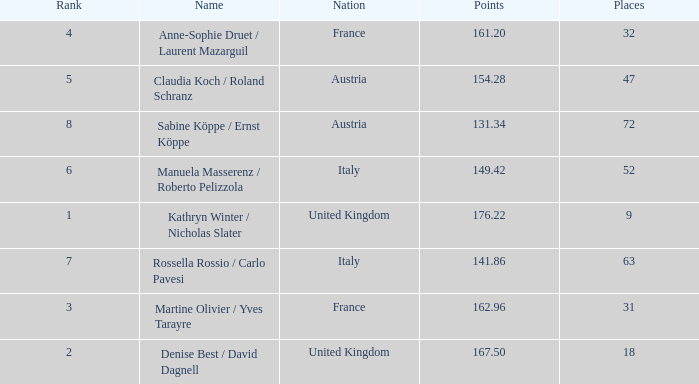Who has points larger than 167.5? Kathryn Winter / Nicholas Slater. 